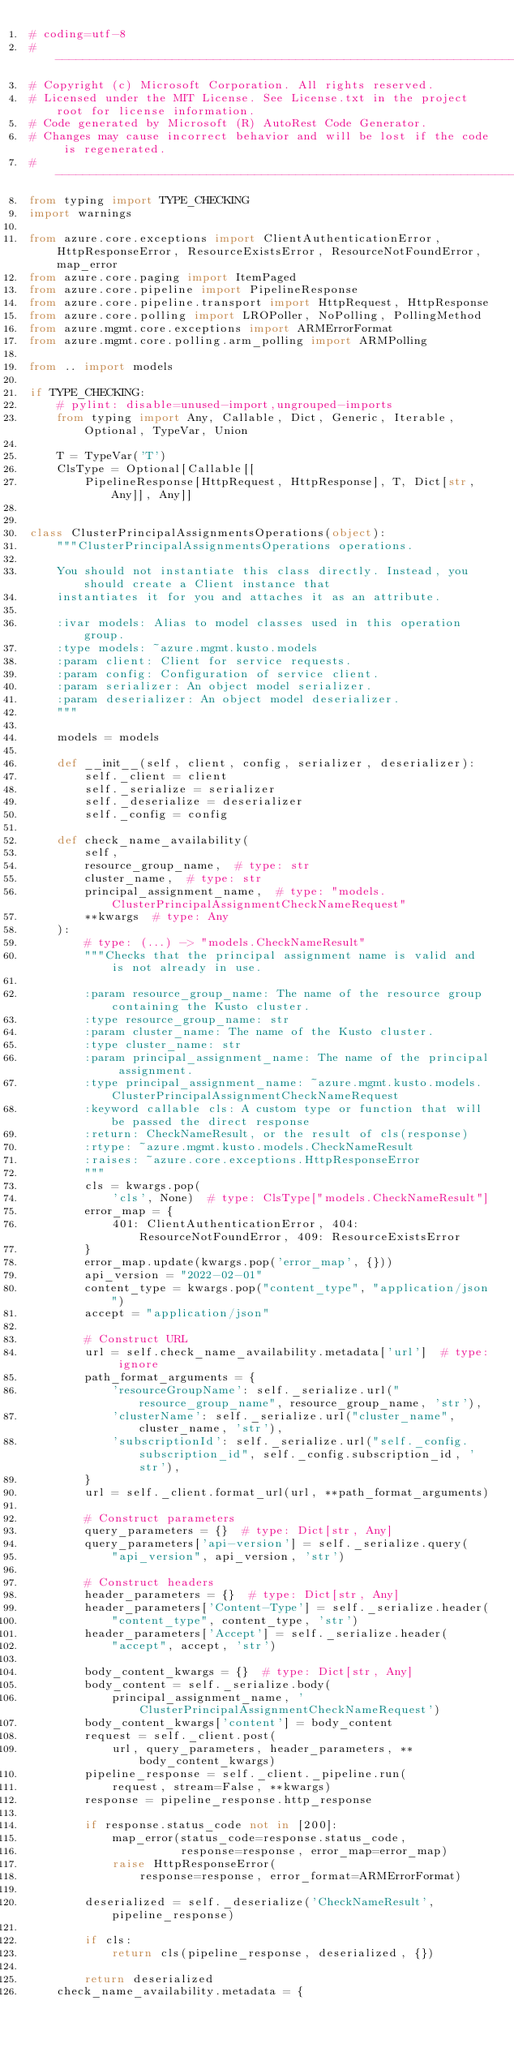Convert code to text. <code><loc_0><loc_0><loc_500><loc_500><_Python_># coding=utf-8
# --------------------------------------------------------------------------
# Copyright (c) Microsoft Corporation. All rights reserved.
# Licensed under the MIT License. See License.txt in the project root for license information.
# Code generated by Microsoft (R) AutoRest Code Generator.
# Changes may cause incorrect behavior and will be lost if the code is regenerated.
# --------------------------------------------------------------------------
from typing import TYPE_CHECKING
import warnings

from azure.core.exceptions import ClientAuthenticationError, HttpResponseError, ResourceExistsError, ResourceNotFoundError, map_error
from azure.core.paging import ItemPaged
from azure.core.pipeline import PipelineResponse
from azure.core.pipeline.transport import HttpRequest, HttpResponse
from azure.core.polling import LROPoller, NoPolling, PollingMethod
from azure.mgmt.core.exceptions import ARMErrorFormat
from azure.mgmt.core.polling.arm_polling import ARMPolling

from .. import models

if TYPE_CHECKING:
    # pylint: disable=unused-import,ungrouped-imports
    from typing import Any, Callable, Dict, Generic, Iterable, Optional, TypeVar, Union

    T = TypeVar('T')
    ClsType = Optional[Callable[[
        PipelineResponse[HttpRequest, HttpResponse], T, Dict[str, Any]], Any]]


class ClusterPrincipalAssignmentsOperations(object):
    """ClusterPrincipalAssignmentsOperations operations.

    You should not instantiate this class directly. Instead, you should create a Client instance that
    instantiates it for you and attaches it as an attribute.

    :ivar models: Alias to model classes used in this operation group.
    :type models: ~azure.mgmt.kusto.models
    :param client: Client for service requests.
    :param config: Configuration of service client.
    :param serializer: An object model serializer.
    :param deserializer: An object model deserializer.
    """

    models = models

    def __init__(self, client, config, serializer, deserializer):
        self._client = client
        self._serialize = serializer
        self._deserialize = deserializer
        self._config = config

    def check_name_availability(
        self,
        resource_group_name,  # type: str
        cluster_name,  # type: str
        principal_assignment_name,  # type: "models.ClusterPrincipalAssignmentCheckNameRequest"
        **kwargs  # type: Any
    ):
        # type: (...) -> "models.CheckNameResult"
        """Checks that the principal assignment name is valid and is not already in use.

        :param resource_group_name: The name of the resource group containing the Kusto cluster.
        :type resource_group_name: str
        :param cluster_name: The name of the Kusto cluster.
        :type cluster_name: str
        :param principal_assignment_name: The name of the principal assignment.
        :type principal_assignment_name: ~azure.mgmt.kusto.models.ClusterPrincipalAssignmentCheckNameRequest
        :keyword callable cls: A custom type or function that will be passed the direct response
        :return: CheckNameResult, or the result of cls(response)
        :rtype: ~azure.mgmt.kusto.models.CheckNameResult
        :raises: ~azure.core.exceptions.HttpResponseError
        """
        cls = kwargs.pop(
            'cls', None)  # type: ClsType["models.CheckNameResult"]
        error_map = {
            401: ClientAuthenticationError, 404: ResourceNotFoundError, 409: ResourceExistsError
        }
        error_map.update(kwargs.pop('error_map', {}))
        api_version = "2022-02-01"
        content_type = kwargs.pop("content_type", "application/json")
        accept = "application/json"

        # Construct URL
        url = self.check_name_availability.metadata['url']  # type: ignore
        path_format_arguments = {
            'resourceGroupName': self._serialize.url("resource_group_name", resource_group_name, 'str'),
            'clusterName': self._serialize.url("cluster_name", cluster_name, 'str'),
            'subscriptionId': self._serialize.url("self._config.subscription_id", self._config.subscription_id, 'str'),
        }
        url = self._client.format_url(url, **path_format_arguments)

        # Construct parameters
        query_parameters = {}  # type: Dict[str, Any]
        query_parameters['api-version'] = self._serialize.query(
            "api_version", api_version, 'str')

        # Construct headers
        header_parameters = {}  # type: Dict[str, Any]
        header_parameters['Content-Type'] = self._serialize.header(
            "content_type", content_type, 'str')
        header_parameters['Accept'] = self._serialize.header(
            "accept", accept, 'str')

        body_content_kwargs = {}  # type: Dict[str, Any]
        body_content = self._serialize.body(
            principal_assignment_name, 'ClusterPrincipalAssignmentCheckNameRequest')
        body_content_kwargs['content'] = body_content
        request = self._client.post(
            url, query_parameters, header_parameters, **body_content_kwargs)
        pipeline_response = self._client._pipeline.run(
            request, stream=False, **kwargs)
        response = pipeline_response.http_response

        if response.status_code not in [200]:
            map_error(status_code=response.status_code,
                      response=response, error_map=error_map)
            raise HttpResponseError(
                response=response, error_format=ARMErrorFormat)

        deserialized = self._deserialize('CheckNameResult', pipeline_response)

        if cls:
            return cls(pipeline_response, deserialized, {})

        return deserialized
    check_name_availability.metadata = {</code> 